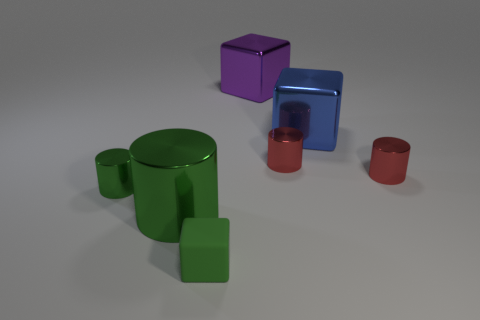There is a metal thing that is the same color as the big cylinder; what size is it?
Keep it short and to the point. Small. What is the color of the tiny metal thing that is to the left of the green matte thing?
Make the answer very short. Green. Does the tiny green shiny thing have the same shape as the large object that is left of the green block?
Your answer should be very brief. Yes. Is there another thing of the same color as the rubber object?
Your response must be concise. Yes. The other block that is the same material as the large blue block is what size?
Your response must be concise. Large. Does the matte cube have the same color as the big cylinder?
Provide a succinct answer. Yes. Does the big metal thing that is on the right side of the large purple thing have the same shape as the small green rubber object?
Your response must be concise. Yes. How many green cylinders have the same size as the purple shiny object?
Give a very brief answer. 1. The small thing that is the same color as the tiny cube is what shape?
Provide a short and direct response. Cylinder. There is a small metal cylinder on the left side of the tiny green matte object; are there any large objects in front of it?
Provide a succinct answer. Yes. 